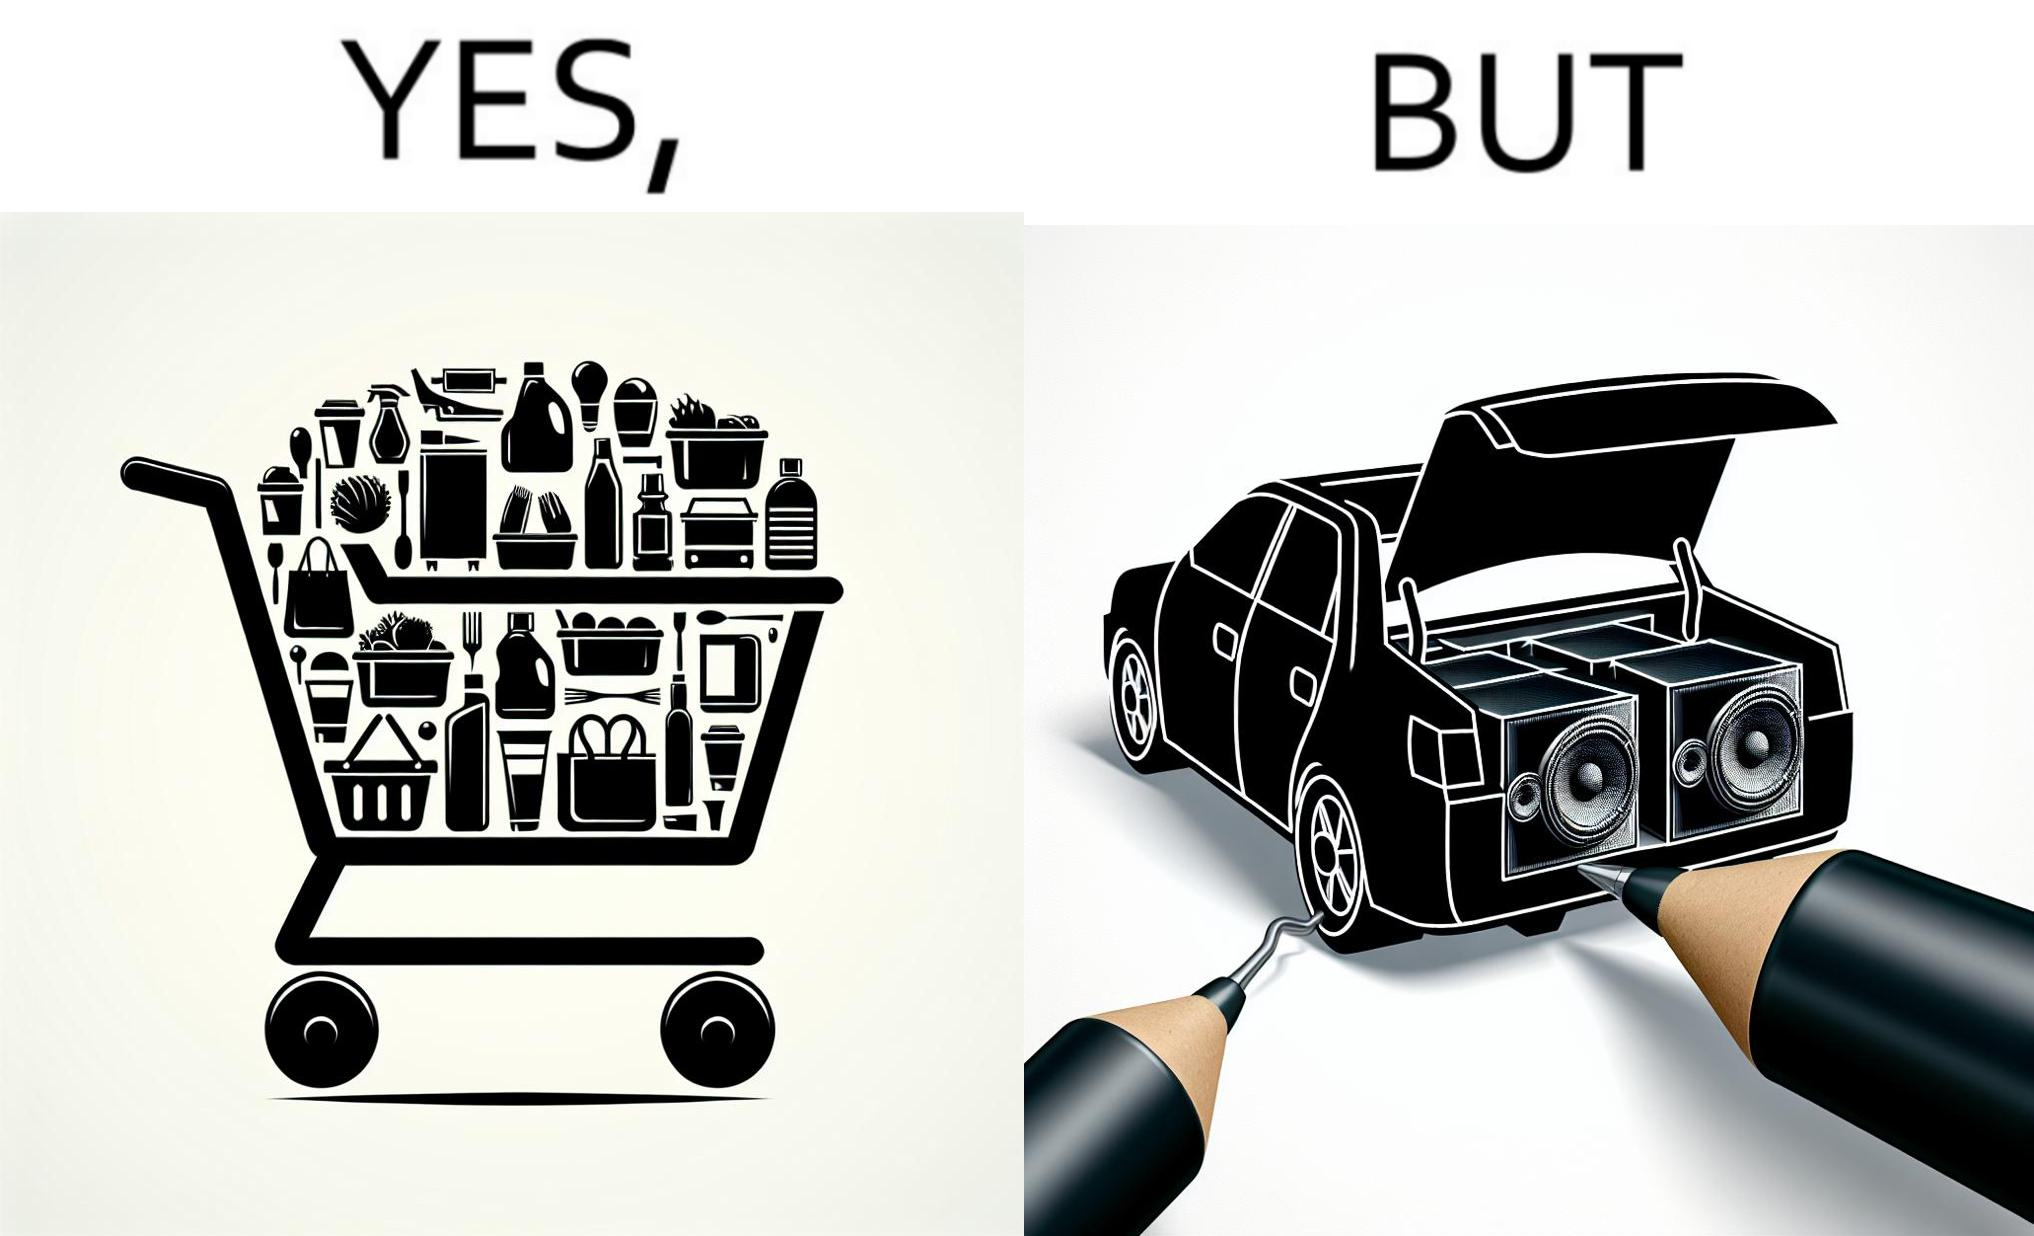Provide a description of this image. The image is ironic, because a car trunk was earlier designed to keep some extra luggage or things but people nowadays get speakers installed in the trunk which in turn reduces the space in the trunk and making it difficult for people to store the extra luggage in the trunk 